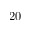Convert formula to latex. <formula><loc_0><loc_0><loc_500><loc_500>2 0</formula> 